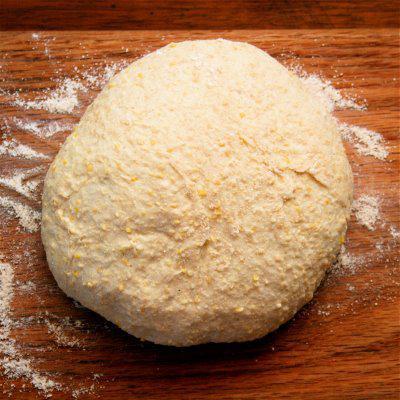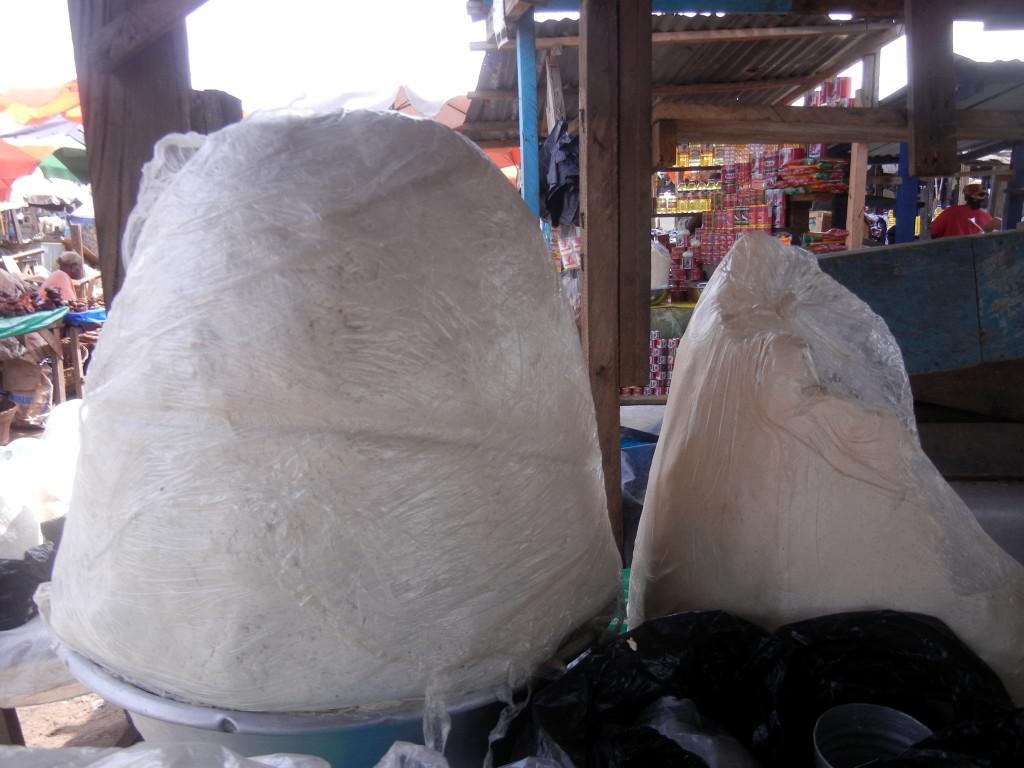The first image is the image on the left, the second image is the image on the right. Examine the images to the left and right. Is the description "One image features one rounded raw dough ball sitting on a flat surface but not in a container." accurate? Answer yes or no. Yes. The first image is the image on the left, the second image is the image on the right. Analyze the images presented: Is the assertion "In at least one image there is a single loaf of bread being made on a single heat source." valid? Answer yes or no. No. 